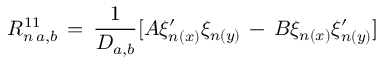<formula> <loc_0><loc_0><loc_500><loc_500>R _ { n \, a , b } ^ { 1 1 } \, = \, \frac { 1 } { D _ { a , b } } [ A \xi _ { n ( x ) } ^ { \prime } \xi _ { n ( y ) } \, - \, B \xi _ { n ( x ) } \xi _ { n ( y ) } ^ { \prime } ]</formula> 